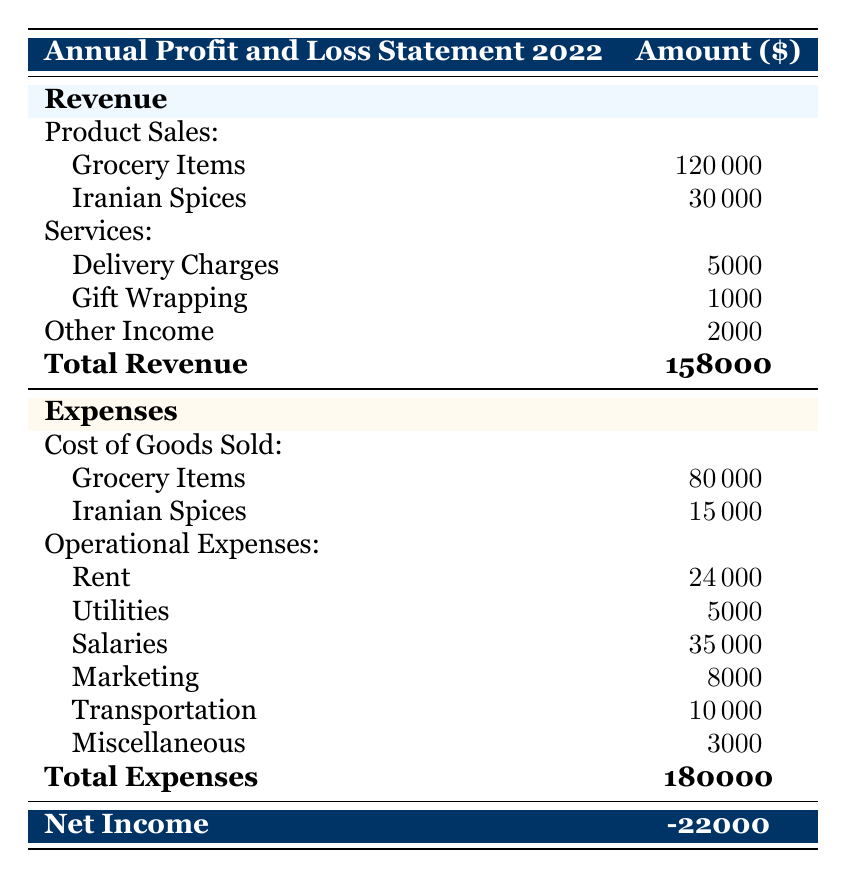What is the total revenue for the store in 2022? The total revenue is listed at the bottom of the revenue section in the table. It is the sum of Product Sales, Services, and Other Income, which amounts to 158000.
Answer: 158000 What is the total expense for the store in 2022? The total expense is provided at the end of the expenses section in the table. It totals 180000.
Answer: 180000 Did the store make a profit in 2022? To determine if the store made a profit, we compare total revenue (158000) and total expenses (180000). Since the total expenses are higher, the store did not make a profit.
Answer: No What was the cost of goods sold for Iranian spices? The cost of goods sold for Iranian spices is explicitly listed in the cost of goods sold section of the table, which is 15000.
Answer: 15000 How much did the store spend on salaries in 2022? The amount spent on salaries is mentioned in the operational expenses section of the table, listed as 35000.
Answer: 35000 What is the net income for the store in 2022? The net income is shown at the bottom of the table and calculated as total revenue minus total expenses, which gives a net income of -22000.
Answer: -22000 What percentage of total revenue came from grocery items? The revenue from grocery items is 120000, and the total revenue is 158000. The percentage is calculated as (120000/158000) * 100, which equals approximately 76.6%.
Answer: 76.6% What was the total amount spent on operational expenses for the store? The total operational expenses include Rent (24000), Utilities (5000), Salaries (35000), Marketing (8000), Transportation (10000), and Miscellaneous (3000). Adding these amounts gives a total of 80000.
Answer: 80000 Was the revenue from Iranian spices higher than the revenue from gift wrapping services? The revenue from Iranian spices is 30000 and from gift wrapping services is 1000. Since 30000 is greater than 1000, the revenue from Iranian spices was indeed higher.
Answer: Yes 